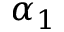<formula> <loc_0><loc_0><loc_500><loc_500>\alpha _ { 1 }</formula> 